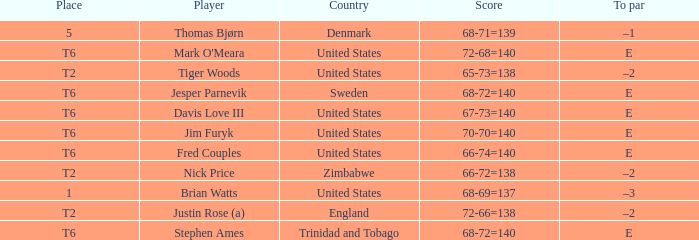What was the TO par for the player who scored 68-69=137? –3. 